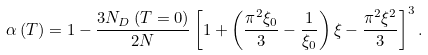Convert formula to latex. <formula><loc_0><loc_0><loc_500><loc_500>\alpha \left ( T \right ) = 1 - \frac { 3 N _ { D } \left ( T = 0 \right ) } { 2 N } \left [ 1 + \left ( \frac { \pi ^ { 2 } \xi _ { 0 } } { 3 } - \frac { 1 } { \xi _ { 0 } } \right ) \xi - \frac { \pi ^ { 2 } \xi ^ { 2 } } { 3 } \right ] ^ { 3 } .</formula> 